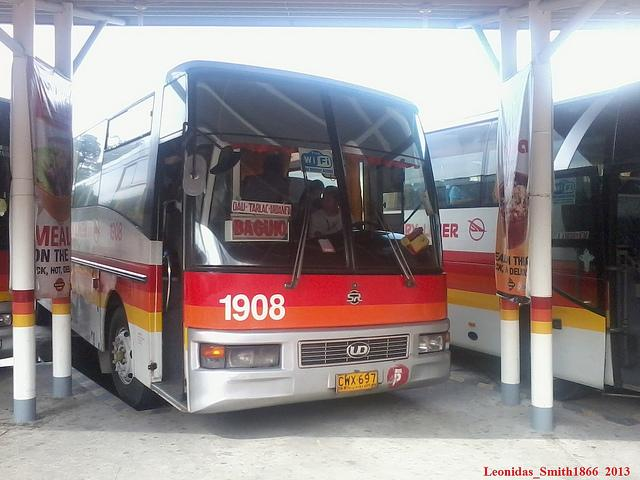What service is available when riding this bus? Please explain your reasoning. wifi. Wifi is available as indicated by the sign on the front. 